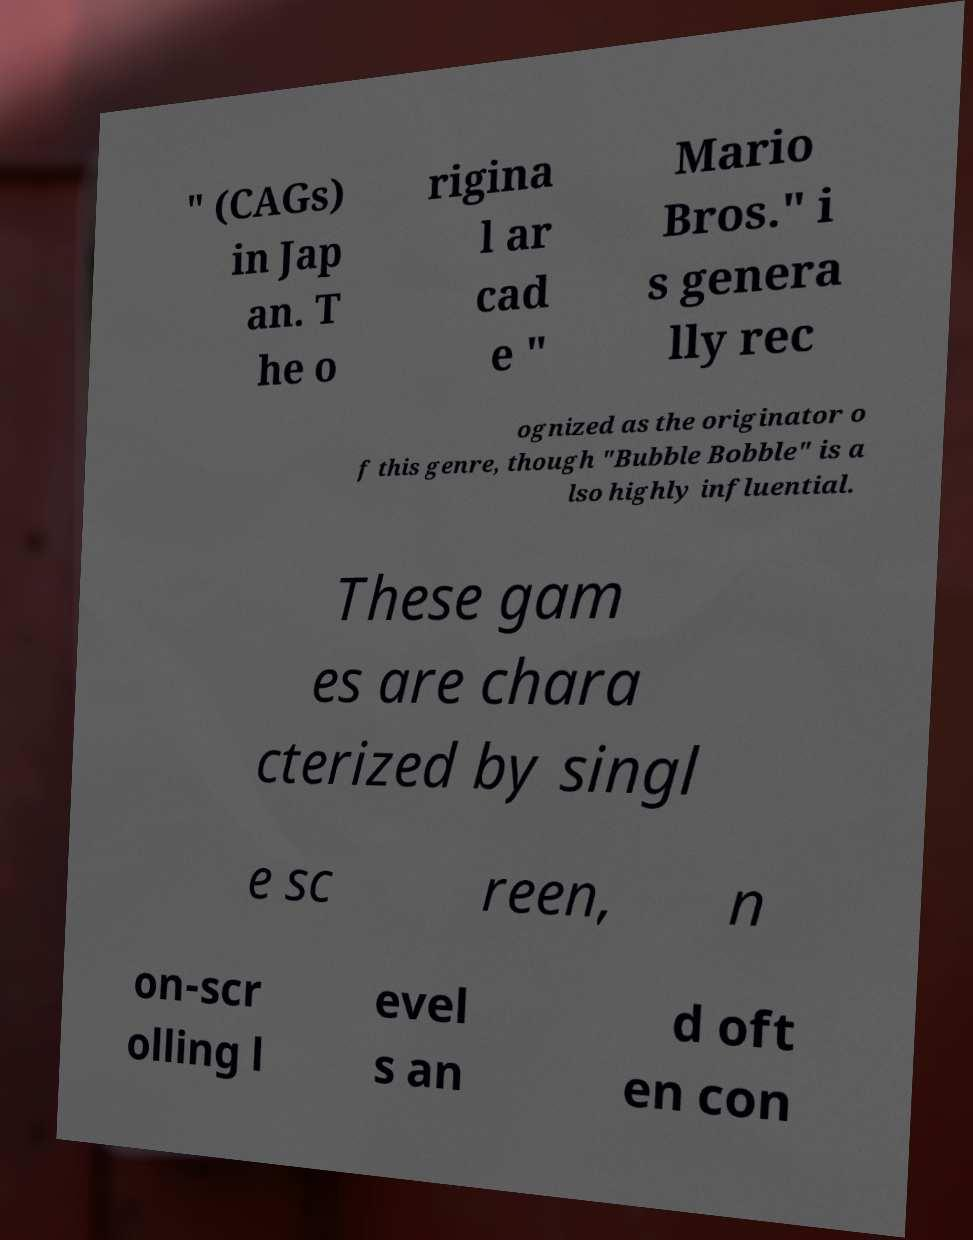Please identify and transcribe the text found in this image. " (CAGs) in Jap an. T he o rigina l ar cad e " Mario Bros." i s genera lly rec ognized as the originator o f this genre, though "Bubble Bobble" is a lso highly influential. These gam es are chara cterized by singl e sc reen, n on-scr olling l evel s an d oft en con 